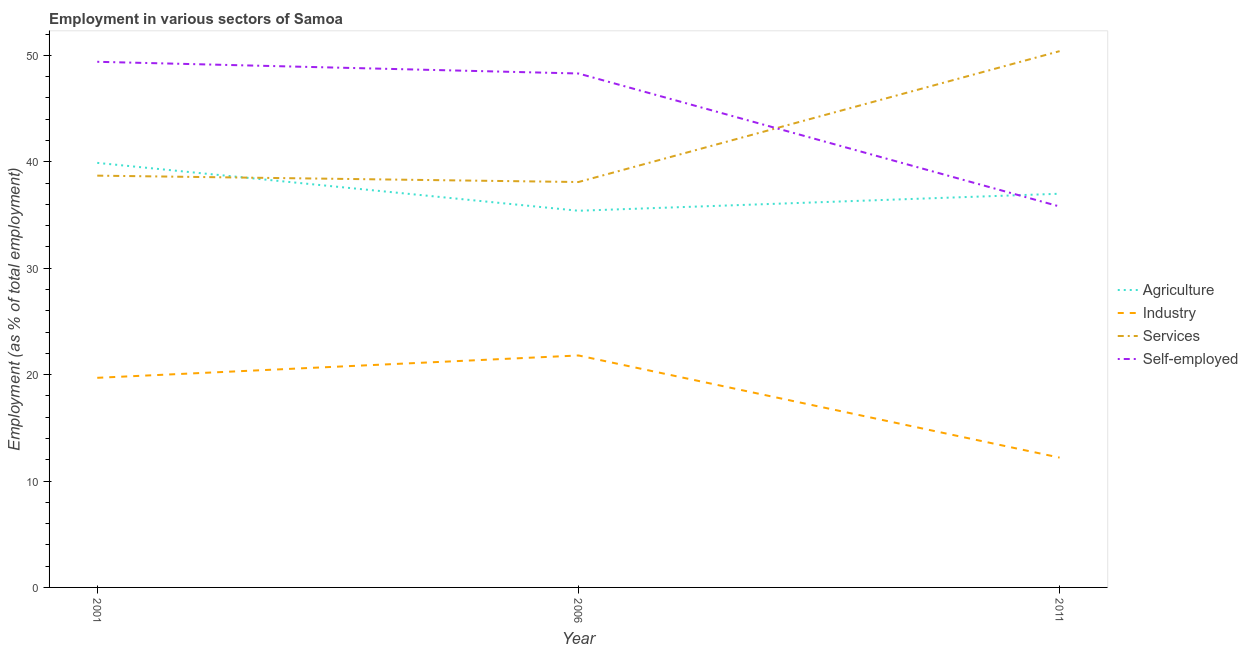What is the percentage of workers in agriculture in 2006?
Your answer should be compact. 35.4. Across all years, what is the maximum percentage of workers in industry?
Your response must be concise. 21.8. Across all years, what is the minimum percentage of self employed workers?
Offer a terse response. 35.8. In which year was the percentage of workers in agriculture minimum?
Ensure brevity in your answer.  2006. What is the total percentage of workers in industry in the graph?
Ensure brevity in your answer.  53.7. What is the difference between the percentage of workers in services in 2006 and that in 2011?
Give a very brief answer. -12.3. What is the difference between the percentage of workers in industry in 2001 and the percentage of workers in agriculture in 2006?
Keep it short and to the point. -15.7. What is the average percentage of workers in services per year?
Offer a terse response. 42.4. In the year 2011, what is the difference between the percentage of workers in industry and percentage of workers in services?
Make the answer very short. -38.2. In how many years, is the percentage of workers in agriculture greater than 2 %?
Provide a succinct answer. 3. What is the ratio of the percentage of workers in agriculture in 2001 to that in 2011?
Your answer should be very brief. 1.08. What is the difference between the highest and the second highest percentage of self employed workers?
Your answer should be compact. 1.1. What is the difference between the highest and the lowest percentage of workers in services?
Ensure brevity in your answer.  12.3. In how many years, is the percentage of workers in industry greater than the average percentage of workers in industry taken over all years?
Provide a short and direct response. 2. Is the sum of the percentage of workers in services in 2001 and 2006 greater than the maximum percentage of self employed workers across all years?
Provide a short and direct response. Yes. Is it the case that in every year, the sum of the percentage of workers in services and percentage of self employed workers is greater than the sum of percentage of workers in agriculture and percentage of workers in industry?
Offer a very short reply. Yes. Is it the case that in every year, the sum of the percentage of workers in agriculture and percentage of workers in industry is greater than the percentage of workers in services?
Offer a very short reply. No. Does the percentage of workers in services monotonically increase over the years?
Provide a succinct answer. No. Is the percentage of workers in services strictly greater than the percentage of workers in industry over the years?
Your response must be concise. Yes. Is the percentage of workers in agriculture strictly less than the percentage of workers in industry over the years?
Your answer should be very brief. No. How many lines are there?
Provide a succinct answer. 4. What is the difference between two consecutive major ticks on the Y-axis?
Make the answer very short. 10. Are the values on the major ticks of Y-axis written in scientific E-notation?
Provide a short and direct response. No. How are the legend labels stacked?
Your answer should be very brief. Vertical. What is the title of the graph?
Keep it short and to the point. Employment in various sectors of Samoa. What is the label or title of the X-axis?
Make the answer very short. Year. What is the label or title of the Y-axis?
Your answer should be very brief. Employment (as % of total employment). What is the Employment (as % of total employment) of Agriculture in 2001?
Offer a terse response. 39.9. What is the Employment (as % of total employment) in Industry in 2001?
Provide a short and direct response. 19.7. What is the Employment (as % of total employment) in Services in 2001?
Your response must be concise. 38.7. What is the Employment (as % of total employment) in Self-employed in 2001?
Offer a terse response. 49.4. What is the Employment (as % of total employment) in Agriculture in 2006?
Provide a short and direct response. 35.4. What is the Employment (as % of total employment) of Industry in 2006?
Your answer should be compact. 21.8. What is the Employment (as % of total employment) of Services in 2006?
Your answer should be very brief. 38.1. What is the Employment (as % of total employment) of Self-employed in 2006?
Your answer should be very brief. 48.3. What is the Employment (as % of total employment) of Agriculture in 2011?
Give a very brief answer. 37. What is the Employment (as % of total employment) of Industry in 2011?
Make the answer very short. 12.2. What is the Employment (as % of total employment) in Services in 2011?
Your response must be concise. 50.4. What is the Employment (as % of total employment) in Self-employed in 2011?
Make the answer very short. 35.8. Across all years, what is the maximum Employment (as % of total employment) in Agriculture?
Ensure brevity in your answer.  39.9. Across all years, what is the maximum Employment (as % of total employment) of Industry?
Your answer should be compact. 21.8. Across all years, what is the maximum Employment (as % of total employment) in Services?
Your answer should be very brief. 50.4. Across all years, what is the maximum Employment (as % of total employment) in Self-employed?
Offer a terse response. 49.4. Across all years, what is the minimum Employment (as % of total employment) in Agriculture?
Your answer should be compact. 35.4. Across all years, what is the minimum Employment (as % of total employment) in Industry?
Offer a very short reply. 12.2. Across all years, what is the minimum Employment (as % of total employment) of Services?
Offer a very short reply. 38.1. Across all years, what is the minimum Employment (as % of total employment) of Self-employed?
Provide a short and direct response. 35.8. What is the total Employment (as % of total employment) in Agriculture in the graph?
Make the answer very short. 112.3. What is the total Employment (as % of total employment) of Industry in the graph?
Give a very brief answer. 53.7. What is the total Employment (as % of total employment) of Services in the graph?
Your response must be concise. 127.2. What is the total Employment (as % of total employment) of Self-employed in the graph?
Keep it short and to the point. 133.5. What is the difference between the Employment (as % of total employment) of Agriculture in 2001 and that in 2006?
Provide a short and direct response. 4.5. What is the difference between the Employment (as % of total employment) of Industry in 2001 and that in 2006?
Provide a short and direct response. -2.1. What is the difference between the Employment (as % of total employment) of Services in 2001 and that in 2006?
Your response must be concise. 0.6. What is the difference between the Employment (as % of total employment) of Agriculture in 2001 and that in 2011?
Your response must be concise. 2.9. What is the difference between the Employment (as % of total employment) of Self-employed in 2001 and that in 2011?
Your answer should be very brief. 13.6. What is the difference between the Employment (as % of total employment) in Self-employed in 2006 and that in 2011?
Provide a succinct answer. 12.5. What is the difference between the Employment (as % of total employment) in Agriculture in 2001 and the Employment (as % of total employment) in Self-employed in 2006?
Ensure brevity in your answer.  -8.4. What is the difference between the Employment (as % of total employment) of Industry in 2001 and the Employment (as % of total employment) of Services in 2006?
Offer a very short reply. -18.4. What is the difference between the Employment (as % of total employment) of Industry in 2001 and the Employment (as % of total employment) of Self-employed in 2006?
Your answer should be compact. -28.6. What is the difference between the Employment (as % of total employment) of Agriculture in 2001 and the Employment (as % of total employment) of Industry in 2011?
Ensure brevity in your answer.  27.7. What is the difference between the Employment (as % of total employment) of Industry in 2001 and the Employment (as % of total employment) of Services in 2011?
Provide a short and direct response. -30.7. What is the difference between the Employment (as % of total employment) of Industry in 2001 and the Employment (as % of total employment) of Self-employed in 2011?
Offer a very short reply. -16.1. What is the difference between the Employment (as % of total employment) of Agriculture in 2006 and the Employment (as % of total employment) of Industry in 2011?
Make the answer very short. 23.2. What is the difference between the Employment (as % of total employment) in Agriculture in 2006 and the Employment (as % of total employment) in Services in 2011?
Offer a terse response. -15. What is the difference between the Employment (as % of total employment) of Industry in 2006 and the Employment (as % of total employment) of Services in 2011?
Offer a terse response. -28.6. What is the difference between the Employment (as % of total employment) in Services in 2006 and the Employment (as % of total employment) in Self-employed in 2011?
Offer a terse response. 2.3. What is the average Employment (as % of total employment) in Agriculture per year?
Provide a succinct answer. 37.43. What is the average Employment (as % of total employment) in Services per year?
Offer a very short reply. 42.4. What is the average Employment (as % of total employment) of Self-employed per year?
Provide a short and direct response. 44.5. In the year 2001, what is the difference between the Employment (as % of total employment) in Agriculture and Employment (as % of total employment) in Industry?
Make the answer very short. 20.2. In the year 2001, what is the difference between the Employment (as % of total employment) in Agriculture and Employment (as % of total employment) in Services?
Provide a short and direct response. 1.2. In the year 2001, what is the difference between the Employment (as % of total employment) in Industry and Employment (as % of total employment) in Services?
Ensure brevity in your answer.  -19. In the year 2001, what is the difference between the Employment (as % of total employment) in Industry and Employment (as % of total employment) in Self-employed?
Keep it short and to the point. -29.7. In the year 2006, what is the difference between the Employment (as % of total employment) in Agriculture and Employment (as % of total employment) in Services?
Give a very brief answer. -2.7. In the year 2006, what is the difference between the Employment (as % of total employment) of Industry and Employment (as % of total employment) of Services?
Your answer should be very brief. -16.3. In the year 2006, what is the difference between the Employment (as % of total employment) of Industry and Employment (as % of total employment) of Self-employed?
Keep it short and to the point. -26.5. In the year 2011, what is the difference between the Employment (as % of total employment) of Agriculture and Employment (as % of total employment) of Industry?
Offer a very short reply. 24.8. In the year 2011, what is the difference between the Employment (as % of total employment) of Agriculture and Employment (as % of total employment) of Services?
Give a very brief answer. -13.4. In the year 2011, what is the difference between the Employment (as % of total employment) in Agriculture and Employment (as % of total employment) in Self-employed?
Your answer should be compact. 1.2. In the year 2011, what is the difference between the Employment (as % of total employment) in Industry and Employment (as % of total employment) in Services?
Your answer should be very brief. -38.2. In the year 2011, what is the difference between the Employment (as % of total employment) of Industry and Employment (as % of total employment) of Self-employed?
Your response must be concise. -23.6. In the year 2011, what is the difference between the Employment (as % of total employment) of Services and Employment (as % of total employment) of Self-employed?
Provide a short and direct response. 14.6. What is the ratio of the Employment (as % of total employment) in Agriculture in 2001 to that in 2006?
Provide a short and direct response. 1.13. What is the ratio of the Employment (as % of total employment) in Industry in 2001 to that in 2006?
Offer a very short reply. 0.9. What is the ratio of the Employment (as % of total employment) of Services in 2001 to that in 2006?
Your response must be concise. 1.02. What is the ratio of the Employment (as % of total employment) in Self-employed in 2001 to that in 2006?
Your answer should be very brief. 1.02. What is the ratio of the Employment (as % of total employment) of Agriculture in 2001 to that in 2011?
Your answer should be very brief. 1.08. What is the ratio of the Employment (as % of total employment) in Industry in 2001 to that in 2011?
Make the answer very short. 1.61. What is the ratio of the Employment (as % of total employment) in Services in 2001 to that in 2011?
Provide a succinct answer. 0.77. What is the ratio of the Employment (as % of total employment) in Self-employed in 2001 to that in 2011?
Offer a terse response. 1.38. What is the ratio of the Employment (as % of total employment) in Agriculture in 2006 to that in 2011?
Your answer should be very brief. 0.96. What is the ratio of the Employment (as % of total employment) of Industry in 2006 to that in 2011?
Offer a very short reply. 1.79. What is the ratio of the Employment (as % of total employment) in Services in 2006 to that in 2011?
Keep it short and to the point. 0.76. What is the ratio of the Employment (as % of total employment) in Self-employed in 2006 to that in 2011?
Offer a very short reply. 1.35. What is the difference between the highest and the second highest Employment (as % of total employment) in Agriculture?
Give a very brief answer. 2.9. What is the difference between the highest and the second highest Employment (as % of total employment) of Services?
Your answer should be compact. 11.7. What is the difference between the highest and the lowest Employment (as % of total employment) in Industry?
Offer a very short reply. 9.6. What is the difference between the highest and the lowest Employment (as % of total employment) of Services?
Your answer should be compact. 12.3. What is the difference between the highest and the lowest Employment (as % of total employment) in Self-employed?
Your answer should be compact. 13.6. 